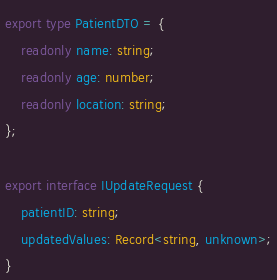<code> <loc_0><loc_0><loc_500><loc_500><_TypeScript_>export type PatientDTO = {
	readonly name: string;
	readonly age: number;
	readonly location: string;
};

export interface IUpdateRequest {
	patientID: string;
	updatedValues: Record<string, unknown>;
}
</code> 